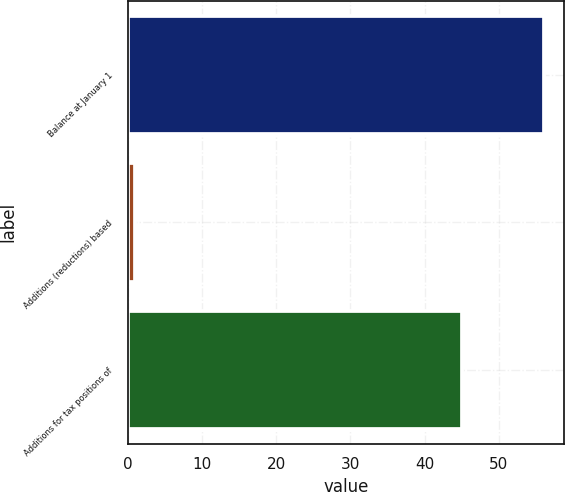Convert chart. <chart><loc_0><loc_0><loc_500><loc_500><bar_chart><fcel>Balance at January 1<fcel>Additions (reductions) based<fcel>Additions for tax positions of<nl><fcel>56<fcel>1<fcel>45<nl></chart> 